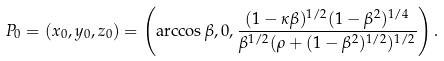<formula> <loc_0><loc_0><loc_500><loc_500>P _ { 0 } = ( x _ { 0 } , y _ { 0 } , z _ { 0 } ) = \left ( \arccos \beta , 0 , \frac { ( 1 - \kappa \beta ) ^ { 1 / 2 } ( 1 - \beta ^ { 2 } ) ^ { 1 / 4 } } { \beta ^ { 1 / 2 } ( \rho + ( 1 - \beta ^ { 2 } ) ^ { 1 / 2 } ) ^ { 1 / 2 } } \right ) .</formula> 